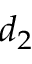<formula> <loc_0><loc_0><loc_500><loc_500>d _ { 2 }</formula> 